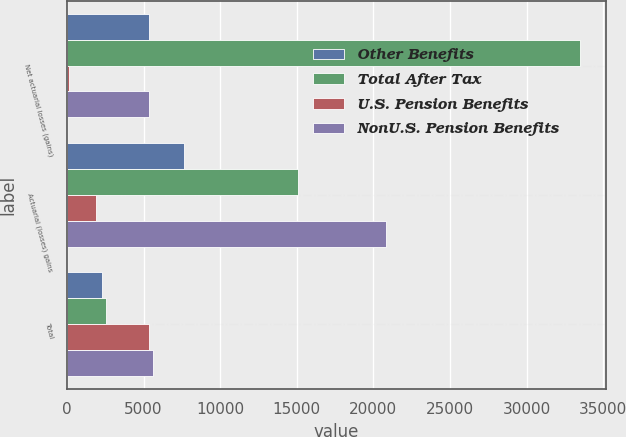Convert chart to OTSL. <chart><loc_0><loc_0><loc_500><loc_500><stacked_bar_chart><ecel><fcel>Net actuarial losses (gains)<fcel>Actuarial (losses) gains<fcel>Total<nl><fcel>Other Benefits<fcel>5337<fcel>7626<fcel>2289<nl><fcel>Total After Tax<fcel>33507<fcel>15084<fcel>2522<nl><fcel>U.S. Pension Benefits<fcel>113<fcel>1877<fcel>5360<nl><fcel>NonU.S. Pension Benefits<fcel>5360<fcel>20833<fcel>5593<nl></chart> 